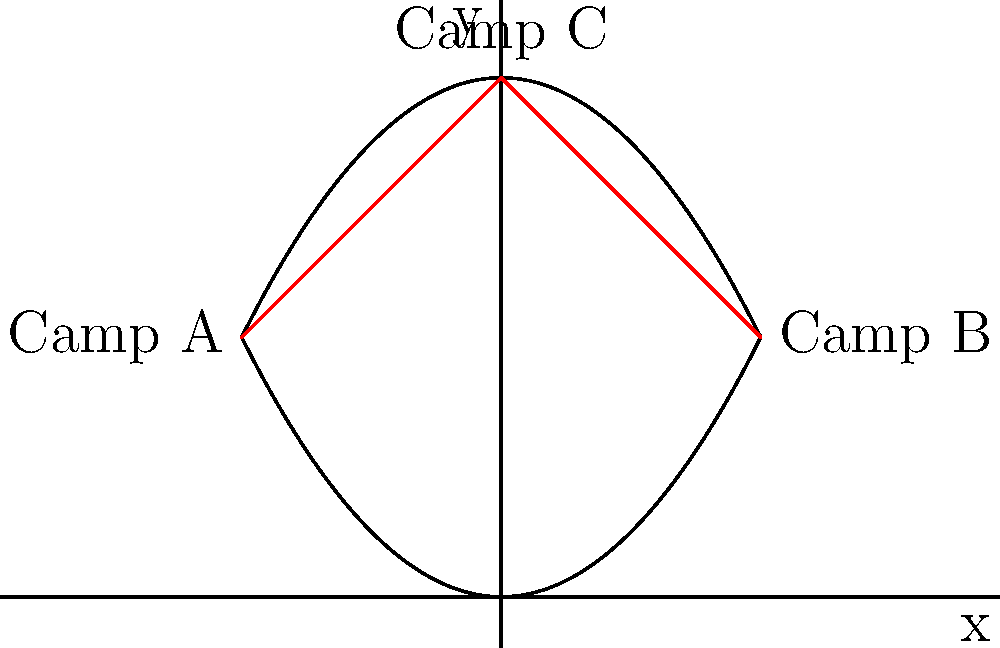In a region affected by a humanitarian crisis, three refugee camps (A, B, and C) are located along two parabolic curves representing geographical features. Camp A is at $(-2, 2)$, Camp B is at $(2, 2)$, and Camp C is at $(0, 4)$. The curves are defined by the equations $y = 0.5x^2$ and $y = -0.5x^2 + 4$. What is the total length of the shortest path connecting all three camps, rounded to two decimal places? To find the shortest path connecting all three camps, we need to:

1. Confirm the coordinates of each camp:
   Camp A: $(-2, 2)$
   Camp B: $(2, 2)$
   Camp C: $(0, 4)$

2. Calculate the distance from Camp A to Camp C:
   $d_{AC} = \sqrt{(0-(-2))^2 + (4-2)^2} = \sqrt{4 + 4} = \sqrt{8} = 2\sqrt{2}$

3. Calculate the distance from Camp C to Camp B:
   $d_{CB} = \sqrt{(2-0)^2 + (2-4)^2} = \sqrt{4 + 4} = \sqrt{8} = 2\sqrt{2}$

4. Sum up the total distance:
   Total distance = $d_{AC} + d_{CB} = 2\sqrt{2} + 2\sqrt{2} = 4\sqrt{2}$

5. Convert $4\sqrt{2}$ to a decimal and round to two decimal places:
   $4\sqrt{2} \approx 5.6568...$
   Rounded to two decimal places: 5.66

Therefore, the total length of the shortest path connecting all three camps is approximately 5.66 units.
Answer: 5.66 units 